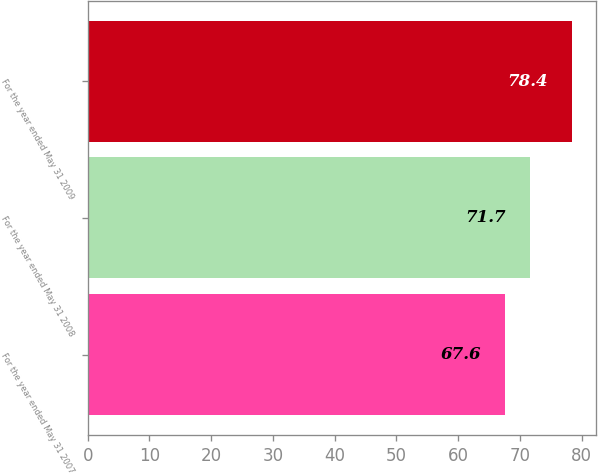Convert chart. <chart><loc_0><loc_0><loc_500><loc_500><bar_chart><fcel>For the year ended May 31 2007<fcel>For the year ended May 31 2008<fcel>For the year ended May 31 2009<nl><fcel>67.6<fcel>71.7<fcel>78.4<nl></chart> 